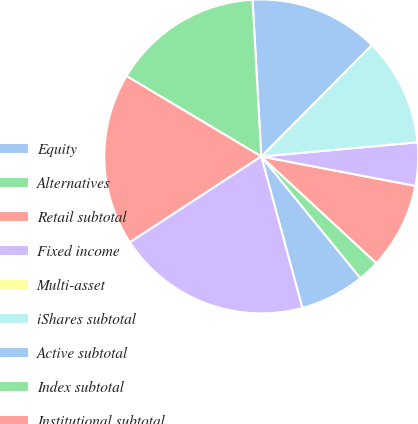Convert chart. <chart><loc_0><loc_0><loc_500><loc_500><pie_chart><fcel>Equity<fcel>Alternatives<fcel>Retail subtotal<fcel>Fixed income<fcel>Multi-asset<fcel>iShares subtotal<fcel>Active subtotal<fcel>Index subtotal<fcel>Institutional subtotal<fcel>Long-term<nl><fcel>6.67%<fcel>2.22%<fcel>8.89%<fcel>4.45%<fcel>0.0%<fcel>11.11%<fcel>13.33%<fcel>15.55%<fcel>17.78%<fcel>20.0%<nl></chart> 